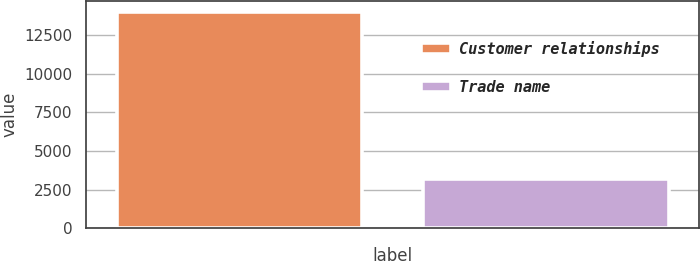Convert chart. <chart><loc_0><loc_0><loc_500><loc_500><bar_chart><fcel>Customer relationships<fcel>Trade name<nl><fcel>13997<fcel>3194<nl></chart> 